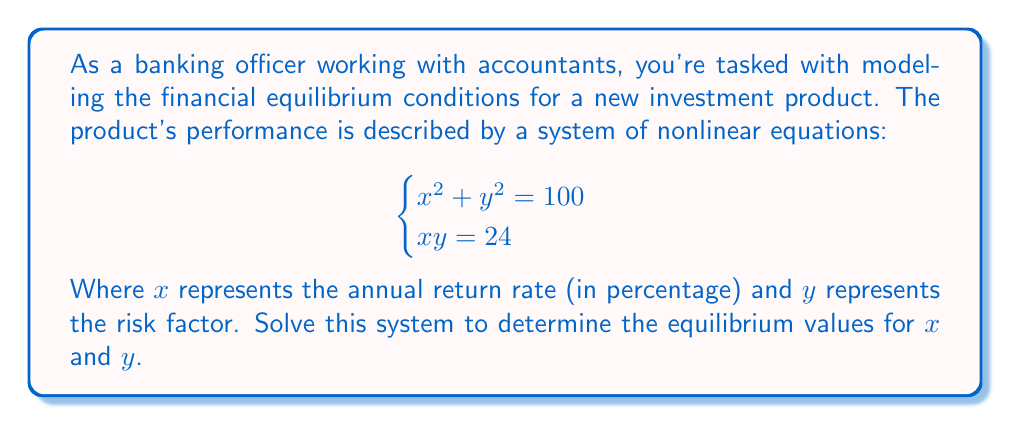Show me your answer to this math problem. Let's solve this system of nonlinear equations step by step:

1) We have two equations:
   $$\begin{cases}
   x^2 + y^2 = 100 \quad (1)\\
   xy = 24 \quad (2)
   \end{cases}$$

2) From equation (2), we can express y in terms of x:
   $$y = \frac{24}{x} \quad (3)$$

3) Substitute (3) into equation (1):
   $$x^2 + (\frac{24}{x})^2 = 100$$

4) Multiply both sides by $x^2$:
   $$x^4 + 576 = 100x^2$$

5) Rearrange the equation:
   $$x^4 - 100x^2 + 576 = 0$$

6) This is a quadratic equation in $x^2$. Let $u = x^2$:
   $$u^2 - 100u + 576 = 0$$

7) Solve this quadratic equation using the quadratic formula:
   $$u = \frac{100 \pm \sqrt{100^2 - 4(1)(576)}}{2(1)}$$
   $$u = \frac{100 \pm \sqrt{10000 - 2304}}{2} = \frac{100 \pm \sqrt{7696}}{2}$$
   $$u = \frac{100 \pm 87.73}{2}$$

8) This gives us two solutions for $u$:
   $$u_1 = \frac{100 + 87.73}{2} = 93.865$$
   $$u_2 = \frac{100 - 87.73}{2} = 6.135$$

9) Since $u = x^2$, we take the square root to find x:
   $$x = \pm \sqrt{93.865} \text{ or } x = \pm \sqrt{6.135}$$

10) Given that x represents a return rate, we consider only the positive values:
    $$x \approx 9.69 \text{ or } x \approx 2.48$$

11) Using equation (3), we can find the corresponding y values:
    $$y \approx \frac{24}{9.69} \approx 2.48 \text{ or } y \approx \frac{24}{2.48} \approx 9.69$$

Therefore, the two solutions are approximately (9.69, 2.48) and (2.48, 9.69).
Answer: (x, y) ≈ (9.69, 2.48) or (2.48, 9.69) 